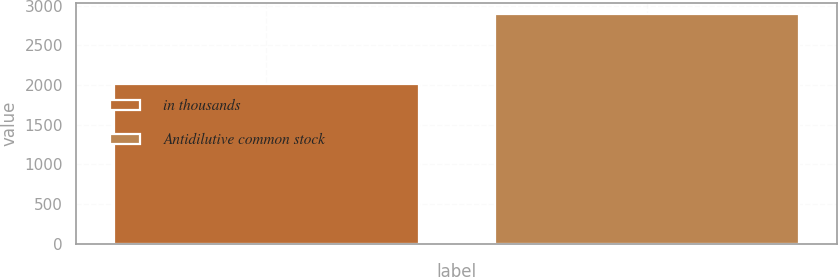Convert chart. <chart><loc_0><loc_0><loc_500><loc_500><bar_chart><fcel>in thousands<fcel>Antidilutive common stock<nl><fcel>2013<fcel>2895<nl></chart> 